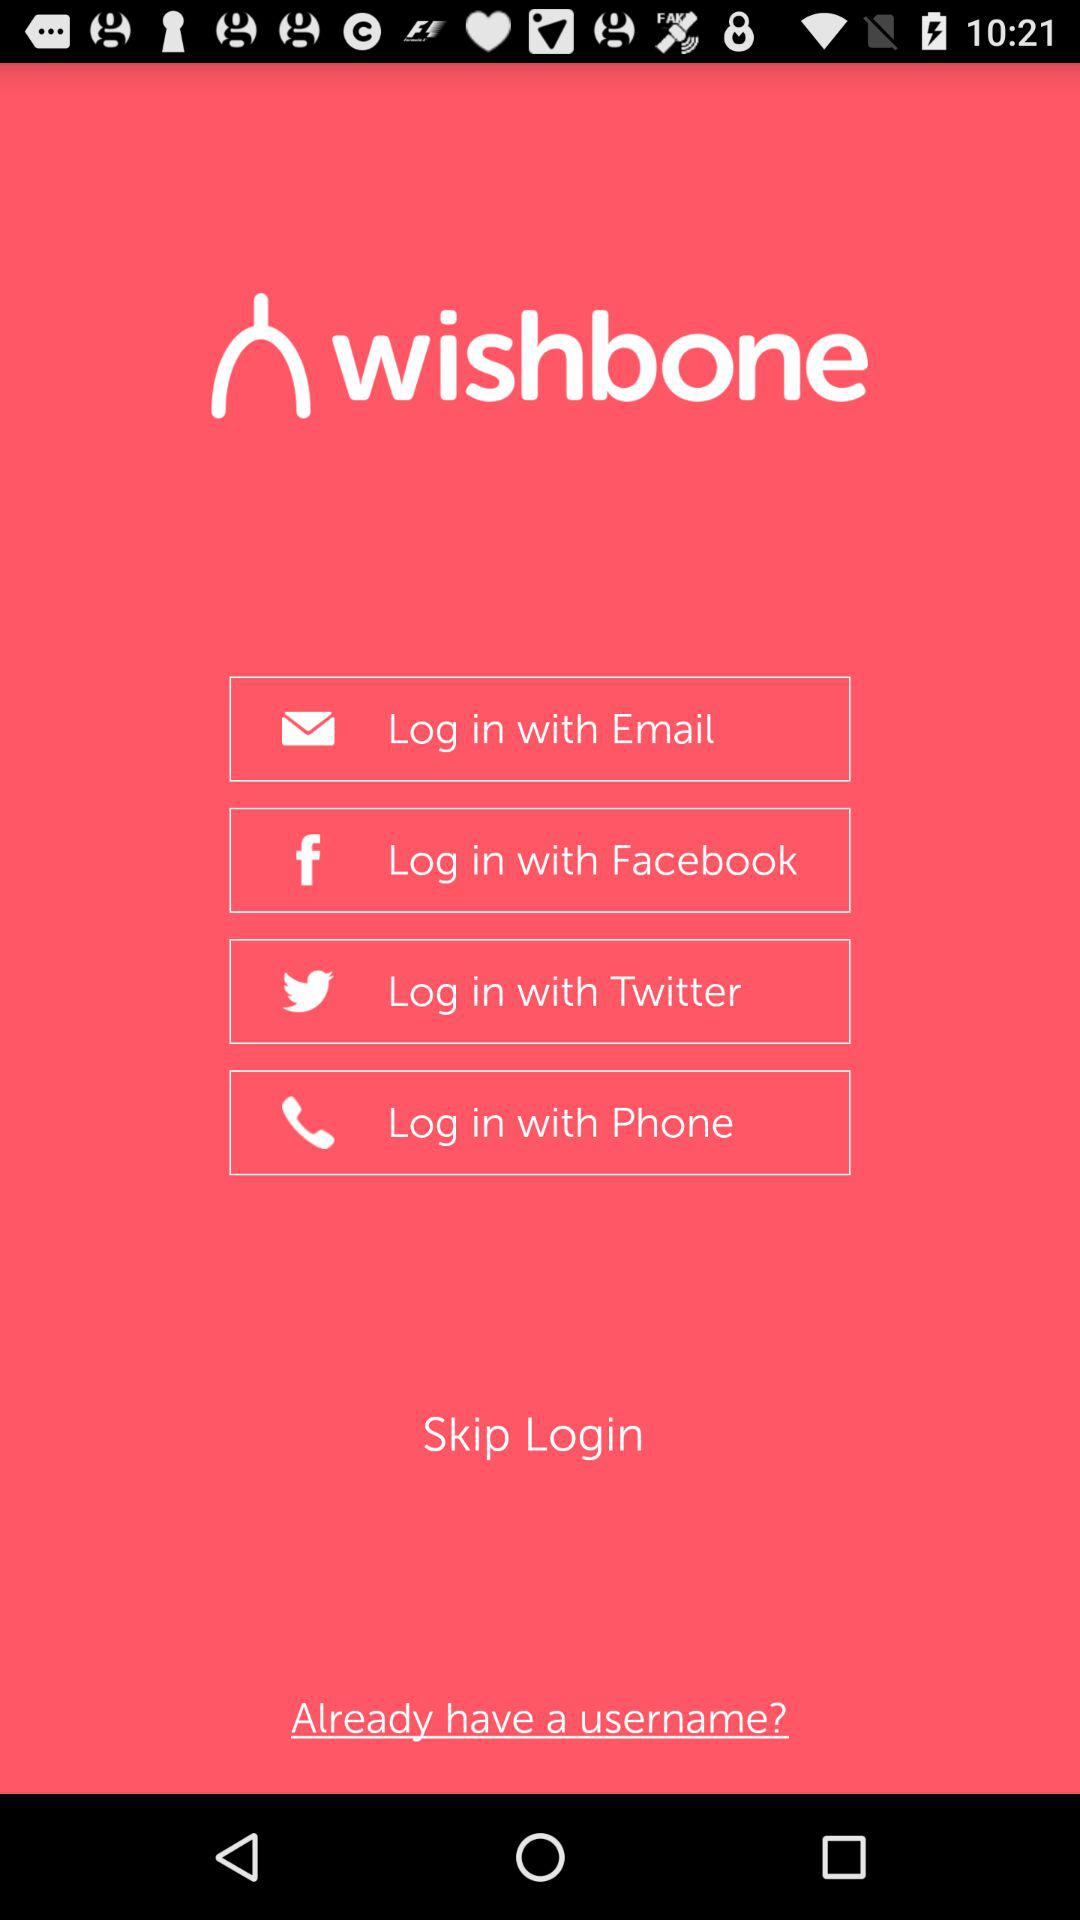How many login options are there?
Answer the question using a single word or phrase. 4 